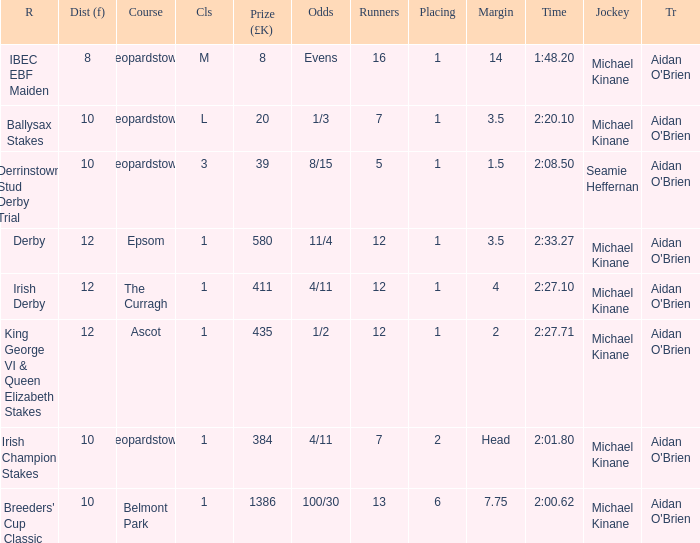Which Class has a Jockey of michael kinane on 2:27.71? 1.0. 